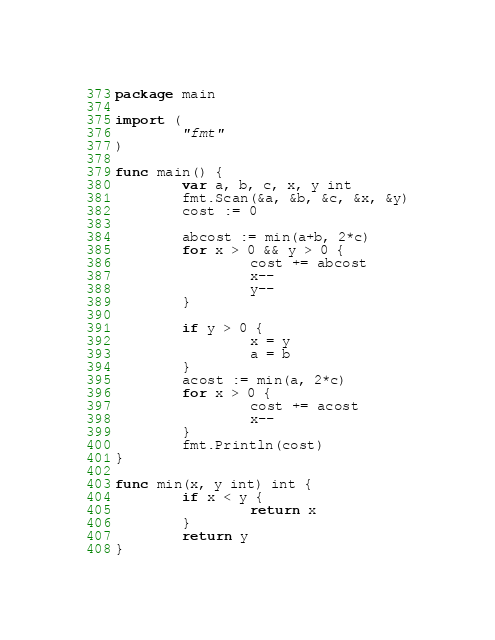<code> <loc_0><loc_0><loc_500><loc_500><_Go_>package main

import (
        "fmt"
)

func main() {
        var a, b, c, x, y int
        fmt.Scan(&a, &b, &c, &x, &y)
        cost := 0

        abcost := min(a+b, 2*c)
        for x > 0 && y > 0 {
                cost += abcost
                x--
                y--
        }

        if y > 0 {
                x = y
                a = b
        }
        acost := min(a, 2*c)
        for x > 0 {
                cost += acost
                x--
        }
        fmt.Println(cost)
}

func min(x, y int) int {
        if x < y {
                return x
        }
        return y
}</code> 